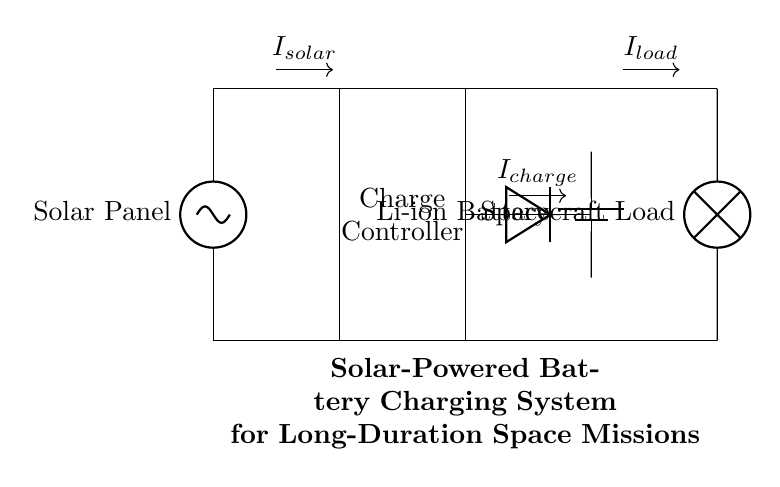What is the main component that generates power? The main component that generates power in the circuit is the solar panel, which converts sunlight into electrical energy.
Answer: Solar Panel What component regulates the charging process? The charge controller is responsible for regulating the voltage and current coming from the solar panel to prevent overcharging the battery.
Answer: Charge Controller What type of battery is used in this system? The circuit uses a lithium-ion battery, as indicated in the diagram, which is known for its efficiency and energy density.
Answer: Li-ion Battery What does the diode do in this circuit? The diode prevents backflow of current from the battery to the solar panel, ensuring that energy flows in one direction only, which protects the panel.
Answer: Prevents backflow What is the role of the load in this system? The load represents the spacecraft's energy demand, consuming the electricity stored in the battery for operational purposes during the mission.
Answer: Spacecraft Load How are the solar panel and charge controller connected? The solar panel connects directly to the charge controller at the top, with a continuous line, indicating direct wiring for power transfer.
Answer: Directly connected What current flows from the charge controller to the battery? The current that flows from the charge controller to the battery is termed as the charging current, depicted in the diagram, denoted as 'I_charge.'
Answer: I_charge 